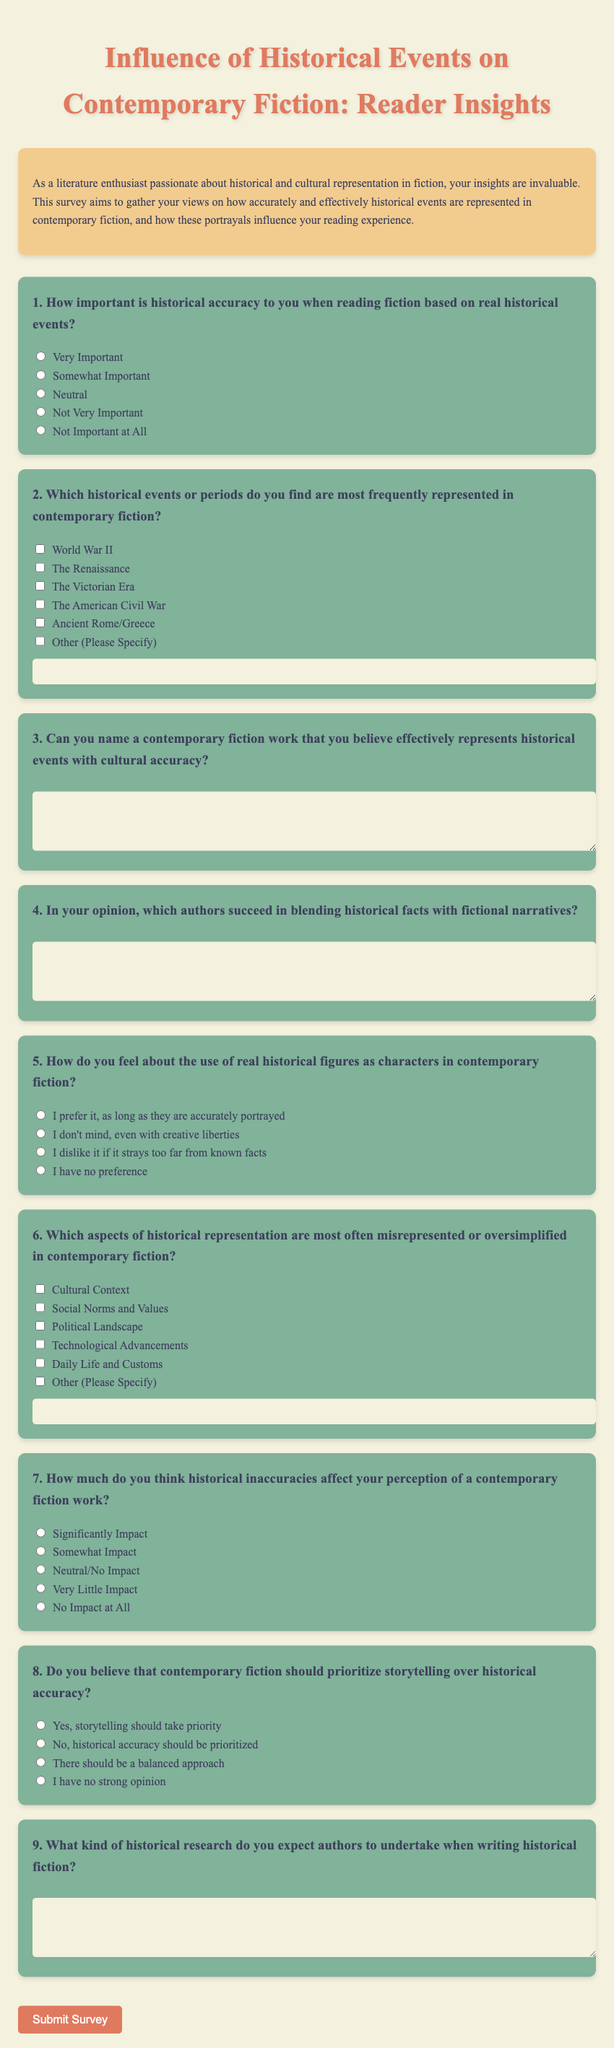What is the title of the survey? The title of the survey is presented prominently at the top of the document.
Answer: Influence of Historical Events on Contemporary Fiction: Reader Insights How many questions are included in the survey? The survey contains a total of nine questions, each focused on different aspects of historical fiction.
Answer: 9 What background color is used for the introductory section? The color of the introduction section provides a visually appealing backdrop that sets the tone for the survey.
Answer: #f2cc8f What type of questions are used for respondents to share opinions on authors? The survey includes open-ended questions to allow for descriptive feedback on authors.
Answer: Open-ended Which historical event is mentioned first in the checkbox options? The order of the checkbox options dictates the sequence in which respondents can select historical events.
Answer: World War II How does the survey classify the question about historical inaccuracies? This question assesses the degree to which inaccuracies are perceived to impact the reading experience.
Answer: Significantly Impact What is the theme of the survey? The theme focuses on understanding the relationship between historical events and their representations in contemporary fiction.
Answer: Historical representation in fiction What form of response is expected for the question about historical research expectations? Respondents are required to answer this question in a text area to detail their expectations.
Answer: Text area What is the color of the button used to submit the survey? The color of the button enhances visibility and encourages respondents to complete the survey.
Answer: #e07a5f 